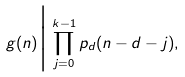<formula> <loc_0><loc_0><loc_500><loc_500>g ( n ) \Big | \prod _ { j = 0 } ^ { k - 1 } p _ { d } ( n - d - j ) ,</formula> 